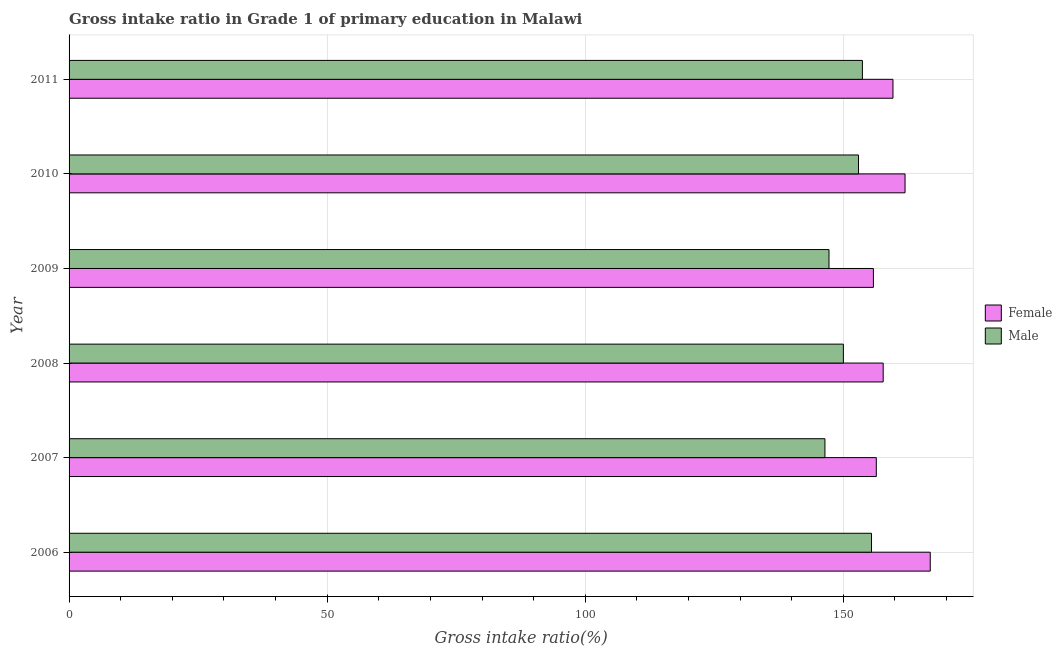How many groups of bars are there?
Offer a terse response. 6. Are the number of bars on each tick of the Y-axis equal?
Provide a succinct answer. Yes. What is the label of the 3rd group of bars from the top?
Provide a succinct answer. 2009. What is the gross intake ratio(female) in 2007?
Ensure brevity in your answer.  156.38. Across all years, what is the maximum gross intake ratio(female)?
Your answer should be compact. 166.83. Across all years, what is the minimum gross intake ratio(male)?
Your answer should be compact. 146.43. What is the total gross intake ratio(male) in the graph?
Offer a very short reply. 905.71. What is the difference between the gross intake ratio(female) in 2007 and that in 2010?
Make the answer very short. -5.56. What is the difference between the gross intake ratio(male) in 2009 and the gross intake ratio(female) in 2008?
Offer a terse response. -10.5. What is the average gross intake ratio(male) per year?
Ensure brevity in your answer.  150.95. In the year 2007, what is the difference between the gross intake ratio(female) and gross intake ratio(male)?
Your answer should be very brief. 9.96. Is the gross intake ratio(female) in 2007 less than that in 2009?
Offer a terse response. No. Is the difference between the gross intake ratio(male) in 2006 and 2008 greater than the difference between the gross intake ratio(female) in 2006 and 2008?
Your answer should be compact. No. What is the difference between the highest and the second highest gross intake ratio(male)?
Make the answer very short. 1.76. What is the difference between the highest and the lowest gross intake ratio(male)?
Offer a terse response. 9.02. In how many years, is the gross intake ratio(female) greater than the average gross intake ratio(female) taken over all years?
Keep it short and to the point. 2. What does the 1st bar from the top in 2011 represents?
Your answer should be very brief. Male. Does the graph contain any zero values?
Your answer should be compact. No. What is the title of the graph?
Ensure brevity in your answer.  Gross intake ratio in Grade 1 of primary education in Malawi. What is the label or title of the X-axis?
Give a very brief answer. Gross intake ratio(%). What is the Gross intake ratio(%) of Female in 2006?
Offer a very short reply. 166.83. What is the Gross intake ratio(%) in Male in 2006?
Your answer should be very brief. 155.45. What is the Gross intake ratio(%) of Female in 2007?
Offer a very short reply. 156.38. What is the Gross intake ratio(%) of Male in 2007?
Offer a very short reply. 146.43. What is the Gross intake ratio(%) in Female in 2008?
Provide a short and direct response. 157.71. What is the Gross intake ratio(%) in Male in 2008?
Offer a very short reply. 150. What is the Gross intake ratio(%) of Female in 2009?
Provide a short and direct response. 155.82. What is the Gross intake ratio(%) of Male in 2009?
Provide a succinct answer. 147.22. What is the Gross intake ratio(%) of Female in 2010?
Keep it short and to the point. 161.95. What is the Gross intake ratio(%) in Male in 2010?
Offer a very short reply. 152.93. What is the Gross intake ratio(%) of Female in 2011?
Provide a succinct answer. 159.61. What is the Gross intake ratio(%) of Male in 2011?
Provide a short and direct response. 153.69. Across all years, what is the maximum Gross intake ratio(%) of Female?
Give a very brief answer. 166.83. Across all years, what is the maximum Gross intake ratio(%) of Male?
Your response must be concise. 155.45. Across all years, what is the minimum Gross intake ratio(%) in Female?
Provide a succinct answer. 155.82. Across all years, what is the minimum Gross intake ratio(%) in Male?
Keep it short and to the point. 146.43. What is the total Gross intake ratio(%) of Female in the graph?
Ensure brevity in your answer.  958.3. What is the total Gross intake ratio(%) in Male in the graph?
Your answer should be very brief. 905.71. What is the difference between the Gross intake ratio(%) in Female in 2006 and that in 2007?
Offer a terse response. 10.45. What is the difference between the Gross intake ratio(%) of Male in 2006 and that in 2007?
Keep it short and to the point. 9.02. What is the difference between the Gross intake ratio(%) of Female in 2006 and that in 2008?
Provide a succinct answer. 9.12. What is the difference between the Gross intake ratio(%) of Male in 2006 and that in 2008?
Make the answer very short. 5.45. What is the difference between the Gross intake ratio(%) of Female in 2006 and that in 2009?
Give a very brief answer. 11.01. What is the difference between the Gross intake ratio(%) of Male in 2006 and that in 2009?
Provide a short and direct response. 8.23. What is the difference between the Gross intake ratio(%) in Female in 2006 and that in 2010?
Make the answer very short. 4.88. What is the difference between the Gross intake ratio(%) of Male in 2006 and that in 2010?
Your response must be concise. 2.52. What is the difference between the Gross intake ratio(%) of Female in 2006 and that in 2011?
Keep it short and to the point. 7.22. What is the difference between the Gross intake ratio(%) of Male in 2006 and that in 2011?
Make the answer very short. 1.76. What is the difference between the Gross intake ratio(%) in Female in 2007 and that in 2008?
Make the answer very short. -1.33. What is the difference between the Gross intake ratio(%) in Male in 2007 and that in 2008?
Give a very brief answer. -3.58. What is the difference between the Gross intake ratio(%) of Female in 2007 and that in 2009?
Ensure brevity in your answer.  0.56. What is the difference between the Gross intake ratio(%) in Male in 2007 and that in 2009?
Provide a short and direct response. -0.79. What is the difference between the Gross intake ratio(%) of Female in 2007 and that in 2010?
Provide a short and direct response. -5.56. What is the difference between the Gross intake ratio(%) in Male in 2007 and that in 2010?
Your response must be concise. -6.5. What is the difference between the Gross intake ratio(%) in Female in 2007 and that in 2011?
Provide a succinct answer. -3.23. What is the difference between the Gross intake ratio(%) of Male in 2007 and that in 2011?
Provide a succinct answer. -7.26. What is the difference between the Gross intake ratio(%) of Female in 2008 and that in 2009?
Provide a short and direct response. 1.89. What is the difference between the Gross intake ratio(%) in Male in 2008 and that in 2009?
Make the answer very short. 2.78. What is the difference between the Gross intake ratio(%) in Female in 2008 and that in 2010?
Offer a very short reply. -4.23. What is the difference between the Gross intake ratio(%) of Male in 2008 and that in 2010?
Your answer should be very brief. -2.93. What is the difference between the Gross intake ratio(%) in Female in 2008 and that in 2011?
Your response must be concise. -1.9. What is the difference between the Gross intake ratio(%) in Male in 2008 and that in 2011?
Offer a very short reply. -3.69. What is the difference between the Gross intake ratio(%) of Female in 2009 and that in 2010?
Provide a short and direct response. -6.13. What is the difference between the Gross intake ratio(%) in Male in 2009 and that in 2010?
Offer a terse response. -5.71. What is the difference between the Gross intake ratio(%) of Female in 2009 and that in 2011?
Provide a succinct answer. -3.79. What is the difference between the Gross intake ratio(%) of Male in 2009 and that in 2011?
Your response must be concise. -6.47. What is the difference between the Gross intake ratio(%) of Female in 2010 and that in 2011?
Your response must be concise. 2.34. What is the difference between the Gross intake ratio(%) in Male in 2010 and that in 2011?
Offer a terse response. -0.76. What is the difference between the Gross intake ratio(%) of Female in 2006 and the Gross intake ratio(%) of Male in 2007?
Ensure brevity in your answer.  20.4. What is the difference between the Gross intake ratio(%) in Female in 2006 and the Gross intake ratio(%) in Male in 2008?
Make the answer very short. 16.83. What is the difference between the Gross intake ratio(%) in Female in 2006 and the Gross intake ratio(%) in Male in 2009?
Ensure brevity in your answer.  19.61. What is the difference between the Gross intake ratio(%) of Female in 2006 and the Gross intake ratio(%) of Male in 2010?
Give a very brief answer. 13.9. What is the difference between the Gross intake ratio(%) in Female in 2006 and the Gross intake ratio(%) in Male in 2011?
Give a very brief answer. 13.14. What is the difference between the Gross intake ratio(%) of Female in 2007 and the Gross intake ratio(%) of Male in 2008?
Make the answer very short. 6.38. What is the difference between the Gross intake ratio(%) of Female in 2007 and the Gross intake ratio(%) of Male in 2009?
Keep it short and to the point. 9.17. What is the difference between the Gross intake ratio(%) in Female in 2007 and the Gross intake ratio(%) in Male in 2010?
Make the answer very short. 3.45. What is the difference between the Gross intake ratio(%) of Female in 2007 and the Gross intake ratio(%) of Male in 2011?
Provide a short and direct response. 2.69. What is the difference between the Gross intake ratio(%) of Female in 2008 and the Gross intake ratio(%) of Male in 2009?
Ensure brevity in your answer.  10.5. What is the difference between the Gross intake ratio(%) in Female in 2008 and the Gross intake ratio(%) in Male in 2010?
Your response must be concise. 4.78. What is the difference between the Gross intake ratio(%) in Female in 2008 and the Gross intake ratio(%) in Male in 2011?
Give a very brief answer. 4.03. What is the difference between the Gross intake ratio(%) in Female in 2009 and the Gross intake ratio(%) in Male in 2010?
Give a very brief answer. 2.89. What is the difference between the Gross intake ratio(%) in Female in 2009 and the Gross intake ratio(%) in Male in 2011?
Offer a terse response. 2.13. What is the difference between the Gross intake ratio(%) in Female in 2010 and the Gross intake ratio(%) in Male in 2011?
Ensure brevity in your answer.  8.26. What is the average Gross intake ratio(%) in Female per year?
Ensure brevity in your answer.  159.72. What is the average Gross intake ratio(%) in Male per year?
Keep it short and to the point. 150.95. In the year 2006, what is the difference between the Gross intake ratio(%) of Female and Gross intake ratio(%) of Male?
Offer a terse response. 11.38. In the year 2007, what is the difference between the Gross intake ratio(%) in Female and Gross intake ratio(%) in Male?
Your response must be concise. 9.96. In the year 2008, what is the difference between the Gross intake ratio(%) in Female and Gross intake ratio(%) in Male?
Provide a short and direct response. 7.71. In the year 2009, what is the difference between the Gross intake ratio(%) of Female and Gross intake ratio(%) of Male?
Ensure brevity in your answer.  8.6. In the year 2010, what is the difference between the Gross intake ratio(%) of Female and Gross intake ratio(%) of Male?
Make the answer very short. 9.02. In the year 2011, what is the difference between the Gross intake ratio(%) of Female and Gross intake ratio(%) of Male?
Ensure brevity in your answer.  5.92. What is the ratio of the Gross intake ratio(%) in Female in 2006 to that in 2007?
Your answer should be very brief. 1.07. What is the ratio of the Gross intake ratio(%) of Male in 2006 to that in 2007?
Keep it short and to the point. 1.06. What is the ratio of the Gross intake ratio(%) of Female in 2006 to that in 2008?
Provide a succinct answer. 1.06. What is the ratio of the Gross intake ratio(%) of Male in 2006 to that in 2008?
Make the answer very short. 1.04. What is the ratio of the Gross intake ratio(%) in Female in 2006 to that in 2009?
Provide a short and direct response. 1.07. What is the ratio of the Gross intake ratio(%) in Male in 2006 to that in 2009?
Offer a terse response. 1.06. What is the ratio of the Gross intake ratio(%) of Female in 2006 to that in 2010?
Your answer should be compact. 1.03. What is the ratio of the Gross intake ratio(%) of Male in 2006 to that in 2010?
Ensure brevity in your answer.  1.02. What is the ratio of the Gross intake ratio(%) of Female in 2006 to that in 2011?
Provide a short and direct response. 1.05. What is the ratio of the Gross intake ratio(%) of Male in 2006 to that in 2011?
Make the answer very short. 1.01. What is the ratio of the Gross intake ratio(%) of Female in 2007 to that in 2008?
Make the answer very short. 0.99. What is the ratio of the Gross intake ratio(%) in Male in 2007 to that in 2008?
Your answer should be compact. 0.98. What is the ratio of the Gross intake ratio(%) of Female in 2007 to that in 2009?
Provide a short and direct response. 1. What is the ratio of the Gross intake ratio(%) in Male in 2007 to that in 2009?
Your answer should be compact. 0.99. What is the ratio of the Gross intake ratio(%) in Female in 2007 to that in 2010?
Keep it short and to the point. 0.97. What is the ratio of the Gross intake ratio(%) in Male in 2007 to that in 2010?
Provide a succinct answer. 0.96. What is the ratio of the Gross intake ratio(%) of Female in 2007 to that in 2011?
Offer a terse response. 0.98. What is the ratio of the Gross intake ratio(%) of Male in 2007 to that in 2011?
Provide a short and direct response. 0.95. What is the ratio of the Gross intake ratio(%) of Female in 2008 to that in 2009?
Ensure brevity in your answer.  1.01. What is the ratio of the Gross intake ratio(%) in Male in 2008 to that in 2009?
Offer a very short reply. 1.02. What is the ratio of the Gross intake ratio(%) of Female in 2008 to that in 2010?
Provide a succinct answer. 0.97. What is the ratio of the Gross intake ratio(%) of Male in 2008 to that in 2010?
Provide a short and direct response. 0.98. What is the ratio of the Gross intake ratio(%) in Female in 2009 to that in 2010?
Offer a terse response. 0.96. What is the ratio of the Gross intake ratio(%) in Male in 2009 to that in 2010?
Give a very brief answer. 0.96. What is the ratio of the Gross intake ratio(%) of Female in 2009 to that in 2011?
Give a very brief answer. 0.98. What is the ratio of the Gross intake ratio(%) of Male in 2009 to that in 2011?
Offer a terse response. 0.96. What is the ratio of the Gross intake ratio(%) of Female in 2010 to that in 2011?
Make the answer very short. 1.01. What is the difference between the highest and the second highest Gross intake ratio(%) in Female?
Your answer should be compact. 4.88. What is the difference between the highest and the second highest Gross intake ratio(%) of Male?
Your response must be concise. 1.76. What is the difference between the highest and the lowest Gross intake ratio(%) of Female?
Provide a short and direct response. 11.01. What is the difference between the highest and the lowest Gross intake ratio(%) of Male?
Your answer should be compact. 9.02. 